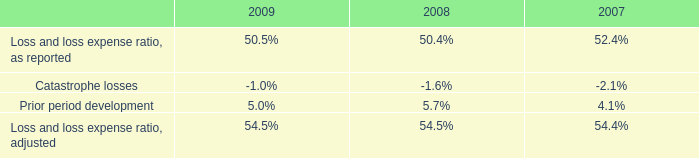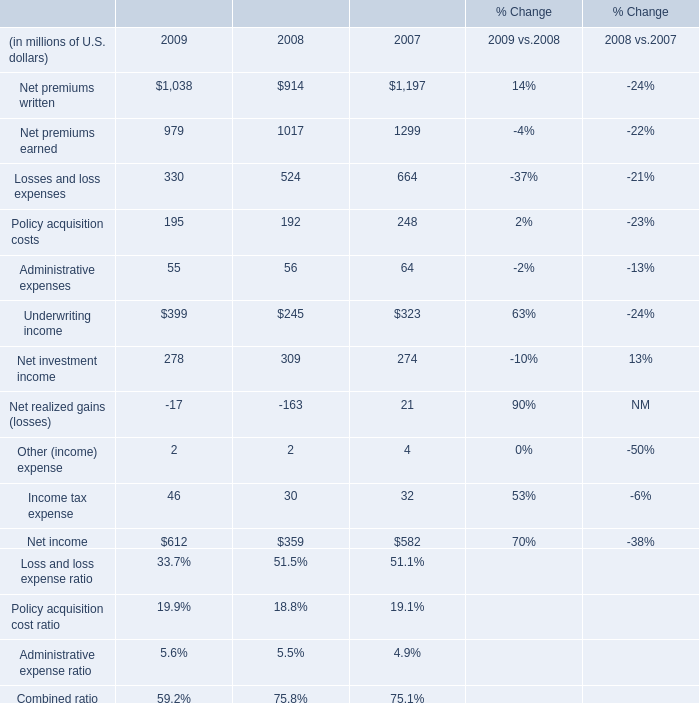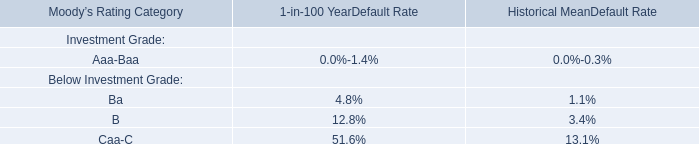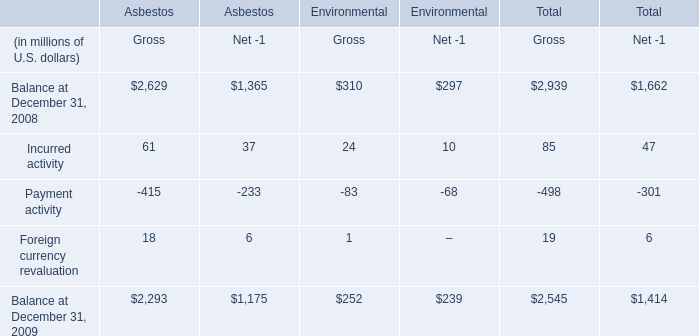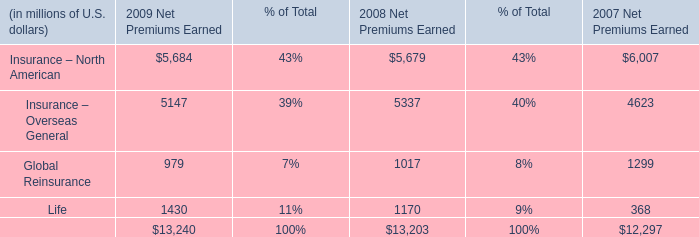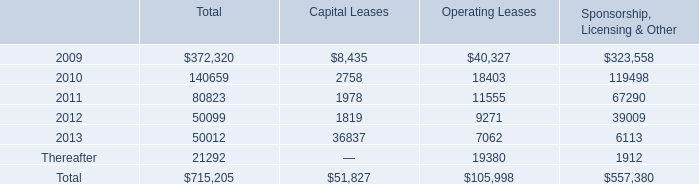What is the average increasing rate of Net premiums written between 2008 and 2009? 
Computations: ((((1038 - 914) / 914) + ((914 - 1197) / 1197)) / 2)
Answer: -0.05038. 